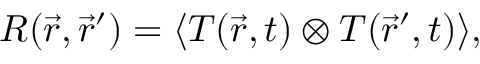<formula> <loc_0><loc_0><loc_500><loc_500>R ( \vec { r } , \vec { r } ^ { \prime } ) = \langle T ( \vec { r } , t ) \otimes T ( \vec { r } ^ { \prime } , t ) \rangle ,</formula> 